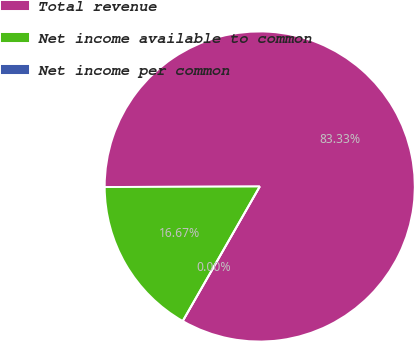Convert chart to OTSL. <chart><loc_0><loc_0><loc_500><loc_500><pie_chart><fcel>Total revenue<fcel>Net income available to common<fcel>Net income per common<nl><fcel>83.33%<fcel>16.67%<fcel>0.0%<nl></chart> 